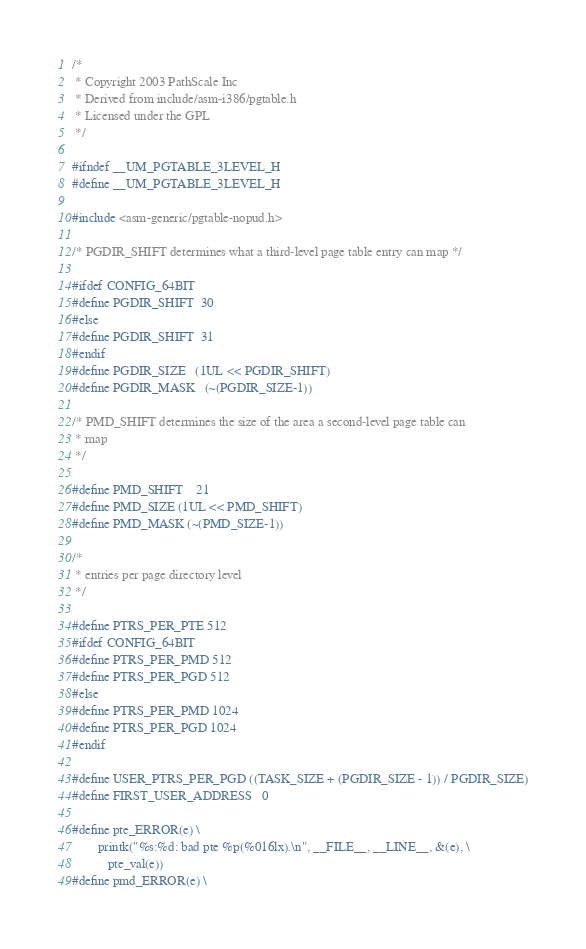Convert code to text. <code><loc_0><loc_0><loc_500><loc_500><_C_>/*
 * Copyright 2003 PathScale Inc
 * Derived from include/asm-i386/pgtable.h
 * Licensed under the GPL
 */

#ifndef __UM_PGTABLE_3LEVEL_H
#define __UM_PGTABLE_3LEVEL_H

#include <asm-generic/pgtable-nopud.h>

/* PGDIR_SHIFT determines what a third-level page table entry can map */

#ifdef CONFIG_64BIT
#define PGDIR_SHIFT	30
#else
#define PGDIR_SHIFT	31
#endif
#define PGDIR_SIZE	(1UL << PGDIR_SHIFT)
#define PGDIR_MASK	(~(PGDIR_SIZE-1))

/* PMD_SHIFT determines the size of the area a second-level page table can
 * map
 */

#define PMD_SHIFT	21
#define PMD_SIZE	(1UL << PMD_SHIFT)
#define PMD_MASK	(~(PMD_SIZE-1))

/*
 * entries per page directory level
 */

#define PTRS_PER_PTE 512
#ifdef CONFIG_64BIT
#define PTRS_PER_PMD 512
#define PTRS_PER_PGD 512
#else
#define PTRS_PER_PMD 1024
#define PTRS_PER_PGD 1024
#endif

#define USER_PTRS_PER_PGD ((TASK_SIZE + (PGDIR_SIZE - 1)) / PGDIR_SIZE)
#define FIRST_USER_ADDRESS	0

#define pte_ERROR(e) \
        printk("%s:%d: bad pte %p(%016lx).\n", __FILE__, __LINE__, &(e), \
	       pte_val(e))
#define pmd_ERROR(e) \</code> 